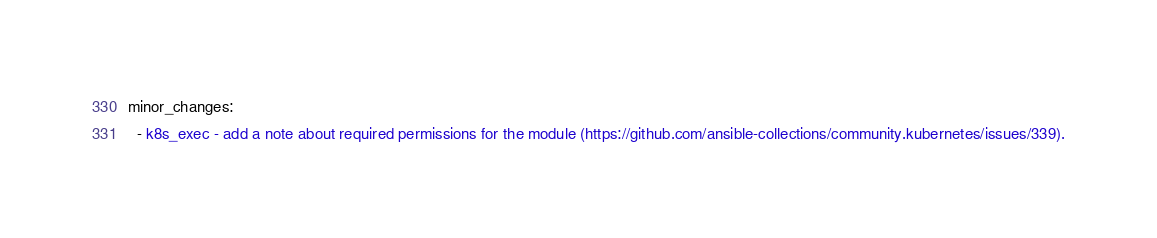Convert code to text. <code><loc_0><loc_0><loc_500><loc_500><_YAML_>minor_changes:
  - k8s_exec - add a note about required permissions for the module (https://github.com/ansible-collections/community.kubernetes/issues/339).
</code> 